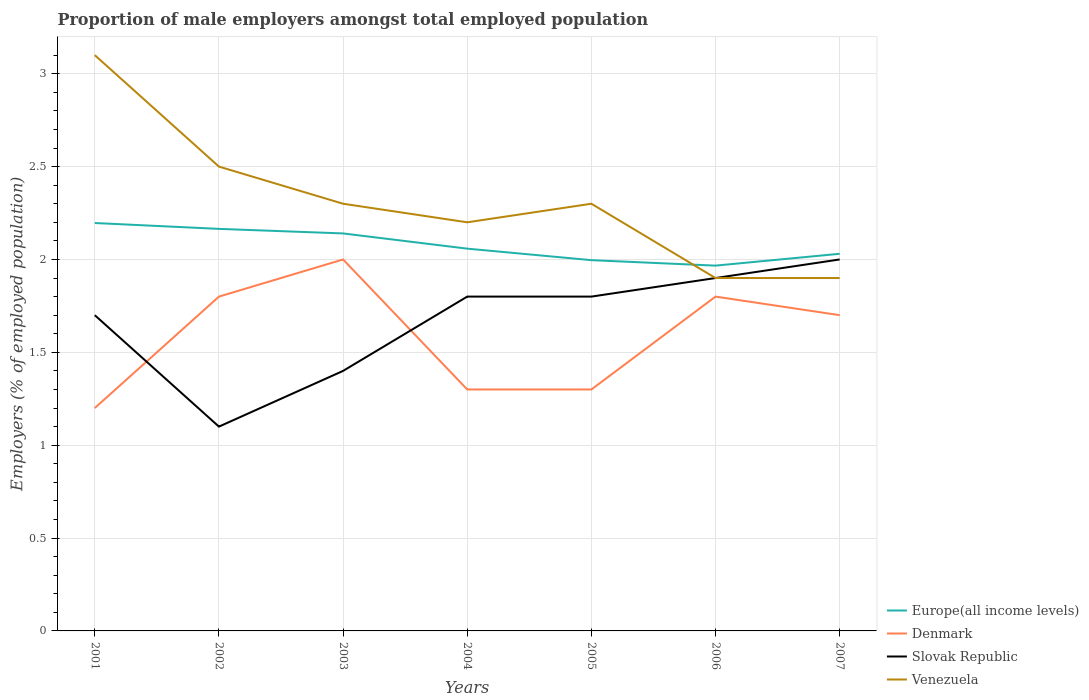How many different coloured lines are there?
Keep it short and to the point. 4. Across all years, what is the maximum proportion of male employers in Venezuela?
Provide a succinct answer. 1.9. In which year was the proportion of male employers in Denmark maximum?
Give a very brief answer. 2001. What is the total proportion of male employers in Denmark in the graph?
Give a very brief answer. -0.1. What is the difference between the highest and the second highest proportion of male employers in Europe(all income levels)?
Give a very brief answer. 0.23. How many years are there in the graph?
Make the answer very short. 7. What is the difference between two consecutive major ticks on the Y-axis?
Ensure brevity in your answer.  0.5. Are the values on the major ticks of Y-axis written in scientific E-notation?
Keep it short and to the point. No. Does the graph contain any zero values?
Your answer should be compact. No. How many legend labels are there?
Ensure brevity in your answer.  4. What is the title of the graph?
Offer a terse response. Proportion of male employers amongst total employed population. What is the label or title of the X-axis?
Provide a succinct answer. Years. What is the label or title of the Y-axis?
Your response must be concise. Employers (% of employed population). What is the Employers (% of employed population) in Europe(all income levels) in 2001?
Provide a short and direct response. 2.2. What is the Employers (% of employed population) of Denmark in 2001?
Your answer should be compact. 1.2. What is the Employers (% of employed population) in Slovak Republic in 2001?
Give a very brief answer. 1.7. What is the Employers (% of employed population) in Venezuela in 2001?
Your answer should be very brief. 3.1. What is the Employers (% of employed population) in Europe(all income levels) in 2002?
Offer a very short reply. 2.16. What is the Employers (% of employed population) of Denmark in 2002?
Your answer should be compact. 1.8. What is the Employers (% of employed population) of Slovak Republic in 2002?
Offer a terse response. 1.1. What is the Employers (% of employed population) of Europe(all income levels) in 2003?
Ensure brevity in your answer.  2.14. What is the Employers (% of employed population) in Denmark in 2003?
Offer a very short reply. 2. What is the Employers (% of employed population) in Slovak Republic in 2003?
Keep it short and to the point. 1.4. What is the Employers (% of employed population) of Venezuela in 2003?
Make the answer very short. 2.3. What is the Employers (% of employed population) in Europe(all income levels) in 2004?
Offer a terse response. 2.06. What is the Employers (% of employed population) in Denmark in 2004?
Provide a short and direct response. 1.3. What is the Employers (% of employed population) in Slovak Republic in 2004?
Ensure brevity in your answer.  1.8. What is the Employers (% of employed population) in Venezuela in 2004?
Give a very brief answer. 2.2. What is the Employers (% of employed population) of Europe(all income levels) in 2005?
Provide a short and direct response. 2. What is the Employers (% of employed population) in Denmark in 2005?
Provide a succinct answer. 1.3. What is the Employers (% of employed population) in Slovak Republic in 2005?
Provide a short and direct response. 1.8. What is the Employers (% of employed population) in Venezuela in 2005?
Give a very brief answer. 2.3. What is the Employers (% of employed population) of Europe(all income levels) in 2006?
Make the answer very short. 1.97. What is the Employers (% of employed population) in Denmark in 2006?
Your answer should be very brief. 1.8. What is the Employers (% of employed population) of Slovak Republic in 2006?
Provide a short and direct response. 1.9. What is the Employers (% of employed population) in Venezuela in 2006?
Offer a terse response. 1.9. What is the Employers (% of employed population) in Europe(all income levels) in 2007?
Your answer should be compact. 2.03. What is the Employers (% of employed population) in Denmark in 2007?
Offer a terse response. 1.7. What is the Employers (% of employed population) in Venezuela in 2007?
Offer a very short reply. 1.9. Across all years, what is the maximum Employers (% of employed population) in Europe(all income levels)?
Ensure brevity in your answer.  2.2. Across all years, what is the maximum Employers (% of employed population) of Denmark?
Your response must be concise. 2. Across all years, what is the maximum Employers (% of employed population) of Slovak Republic?
Your answer should be very brief. 2. Across all years, what is the maximum Employers (% of employed population) in Venezuela?
Make the answer very short. 3.1. Across all years, what is the minimum Employers (% of employed population) in Europe(all income levels)?
Offer a very short reply. 1.97. Across all years, what is the minimum Employers (% of employed population) of Denmark?
Your answer should be very brief. 1.2. Across all years, what is the minimum Employers (% of employed population) of Slovak Republic?
Make the answer very short. 1.1. Across all years, what is the minimum Employers (% of employed population) in Venezuela?
Your response must be concise. 1.9. What is the total Employers (% of employed population) of Europe(all income levels) in the graph?
Give a very brief answer. 14.55. What is the difference between the Employers (% of employed population) of Europe(all income levels) in 2001 and that in 2002?
Your response must be concise. 0.03. What is the difference between the Employers (% of employed population) in Venezuela in 2001 and that in 2002?
Your response must be concise. 0.6. What is the difference between the Employers (% of employed population) of Europe(all income levels) in 2001 and that in 2003?
Provide a succinct answer. 0.06. What is the difference between the Employers (% of employed population) of Slovak Republic in 2001 and that in 2003?
Give a very brief answer. 0.3. What is the difference between the Employers (% of employed population) in Venezuela in 2001 and that in 2003?
Provide a succinct answer. 0.8. What is the difference between the Employers (% of employed population) of Europe(all income levels) in 2001 and that in 2004?
Your response must be concise. 0.14. What is the difference between the Employers (% of employed population) in Slovak Republic in 2001 and that in 2004?
Your answer should be very brief. -0.1. What is the difference between the Employers (% of employed population) of Venezuela in 2001 and that in 2004?
Ensure brevity in your answer.  0.9. What is the difference between the Employers (% of employed population) of Europe(all income levels) in 2001 and that in 2005?
Your answer should be compact. 0.2. What is the difference between the Employers (% of employed population) in Venezuela in 2001 and that in 2005?
Offer a very short reply. 0.8. What is the difference between the Employers (% of employed population) of Europe(all income levels) in 2001 and that in 2006?
Ensure brevity in your answer.  0.23. What is the difference between the Employers (% of employed population) of Denmark in 2001 and that in 2006?
Your answer should be compact. -0.6. What is the difference between the Employers (% of employed population) of Slovak Republic in 2001 and that in 2006?
Offer a very short reply. -0.2. What is the difference between the Employers (% of employed population) of Europe(all income levels) in 2001 and that in 2007?
Provide a short and direct response. 0.17. What is the difference between the Employers (% of employed population) of Denmark in 2001 and that in 2007?
Your answer should be very brief. -0.5. What is the difference between the Employers (% of employed population) in Slovak Republic in 2001 and that in 2007?
Ensure brevity in your answer.  -0.3. What is the difference between the Employers (% of employed population) in Venezuela in 2001 and that in 2007?
Offer a very short reply. 1.2. What is the difference between the Employers (% of employed population) of Europe(all income levels) in 2002 and that in 2003?
Keep it short and to the point. 0.02. What is the difference between the Employers (% of employed population) of Denmark in 2002 and that in 2003?
Keep it short and to the point. -0.2. What is the difference between the Employers (% of employed population) in Slovak Republic in 2002 and that in 2003?
Ensure brevity in your answer.  -0.3. What is the difference between the Employers (% of employed population) in Venezuela in 2002 and that in 2003?
Provide a succinct answer. 0.2. What is the difference between the Employers (% of employed population) in Europe(all income levels) in 2002 and that in 2004?
Give a very brief answer. 0.11. What is the difference between the Employers (% of employed population) of Denmark in 2002 and that in 2004?
Give a very brief answer. 0.5. What is the difference between the Employers (% of employed population) in Slovak Republic in 2002 and that in 2004?
Your response must be concise. -0.7. What is the difference between the Employers (% of employed population) of Europe(all income levels) in 2002 and that in 2005?
Give a very brief answer. 0.17. What is the difference between the Employers (% of employed population) in Venezuela in 2002 and that in 2005?
Your answer should be compact. 0.2. What is the difference between the Employers (% of employed population) of Europe(all income levels) in 2002 and that in 2006?
Keep it short and to the point. 0.2. What is the difference between the Employers (% of employed population) in Venezuela in 2002 and that in 2006?
Provide a succinct answer. 0.6. What is the difference between the Employers (% of employed population) of Europe(all income levels) in 2002 and that in 2007?
Make the answer very short. 0.13. What is the difference between the Employers (% of employed population) of Denmark in 2002 and that in 2007?
Your answer should be very brief. 0.1. What is the difference between the Employers (% of employed population) in Slovak Republic in 2002 and that in 2007?
Make the answer very short. -0.9. What is the difference between the Employers (% of employed population) in Europe(all income levels) in 2003 and that in 2004?
Your answer should be very brief. 0.08. What is the difference between the Employers (% of employed population) of Denmark in 2003 and that in 2004?
Your answer should be very brief. 0.7. What is the difference between the Employers (% of employed population) in Slovak Republic in 2003 and that in 2004?
Give a very brief answer. -0.4. What is the difference between the Employers (% of employed population) of Venezuela in 2003 and that in 2004?
Ensure brevity in your answer.  0.1. What is the difference between the Employers (% of employed population) in Europe(all income levels) in 2003 and that in 2005?
Ensure brevity in your answer.  0.14. What is the difference between the Employers (% of employed population) in Europe(all income levels) in 2003 and that in 2006?
Your answer should be compact. 0.17. What is the difference between the Employers (% of employed population) of Denmark in 2003 and that in 2006?
Your answer should be very brief. 0.2. What is the difference between the Employers (% of employed population) in Venezuela in 2003 and that in 2006?
Offer a very short reply. 0.4. What is the difference between the Employers (% of employed population) in Europe(all income levels) in 2003 and that in 2007?
Ensure brevity in your answer.  0.11. What is the difference between the Employers (% of employed population) of Venezuela in 2003 and that in 2007?
Your response must be concise. 0.4. What is the difference between the Employers (% of employed population) in Europe(all income levels) in 2004 and that in 2005?
Your answer should be very brief. 0.06. What is the difference between the Employers (% of employed population) in Europe(all income levels) in 2004 and that in 2006?
Your response must be concise. 0.09. What is the difference between the Employers (% of employed population) of Denmark in 2004 and that in 2006?
Provide a short and direct response. -0.5. What is the difference between the Employers (% of employed population) in Venezuela in 2004 and that in 2006?
Ensure brevity in your answer.  0.3. What is the difference between the Employers (% of employed population) of Europe(all income levels) in 2004 and that in 2007?
Keep it short and to the point. 0.03. What is the difference between the Employers (% of employed population) in Denmark in 2004 and that in 2007?
Your answer should be compact. -0.4. What is the difference between the Employers (% of employed population) of Venezuela in 2004 and that in 2007?
Your answer should be very brief. 0.3. What is the difference between the Employers (% of employed population) in Europe(all income levels) in 2005 and that in 2006?
Your answer should be very brief. 0.03. What is the difference between the Employers (% of employed population) in Denmark in 2005 and that in 2006?
Ensure brevity in your answer.  -0.5. What is the difference between the Employers (% of employed population) in Slovak Republic in 2005 and that in 2006?
Ensure brevity in your answer.  -0.1. What is the difference between the Employers (% of employed population) in Venezuela in 2005 and that in 2006?
Your answer should be very brief. 0.4. What is the difference between the Employers (% of employed population) in Europe(all income levels) in 2005 and that in 2007?
Offer a very short reply. -0.03. What is the difference between the Employers (% of employed population) of Denmark in 2005 and that in 2007?
Provide a short and direct response. -0.4. What is the difference between the Employers (% of employed population) of Slovak Republic in 2005 and that in 2007?
Provide a short and direct response. -0.2. What is the difference between the Employers (% of employed population) of Europe(all income levels) in 2006 and that in 2007?
Offer a very short reply. -0.06. What is the difference between the Employers (% of employed population) in Denmark in 2006 and that in 2007?
Make the answer very short. 0.1. What is the difference between the Employers (% of employed population) in Slovak Republic in 2006 and that in 2007?
Keep it short and to the point. -0.1. What is the difference between the Employers (% of employed population) of Venezuela in 2006 and that in 2007?
Your answer should be very brief. 0. What is the difference between the Employers (% of employed population) of Europe(all income levels) in 2001 and the Employers (% of employed population) of Denmark in 2002?
Keep it short and to the point. 0.4. What is the difference between the Employers (% of employed population) of Europe(all income levels) in 2001 and the Employers (% of employed population) of Slovak Republic in 2002?
Your response must be concise. 1.1. What is the difference between the Employers (% of employed population) of Europe(all income levels) in 2001 and the Employers (% of employed population) of Venezuela in 2002?
Keep it short and to the point. -0.3. What is the difference between the Employers (% of employed population) in Denmark in 2001 and the Employers (% of employed population) in Slovak Republic in 2002?
Provide a succinct answer. 0.1. What is the difference between the Employers (% of employed population) in Europe(all income levels) in 2001 and the Employers (% of employed population) in Denmark in 2003?
Your answer should be compact. 0.2. What is the difference between the Employers (% of employed population) in Europe(all income levels) in 2001 and the Employers (% of employed population) in Slovak Republic in 2003?
Make the answer very short. 0.8. What is the difference between the Employers (% of employed population) in Europe(all income levels) in 2001 and the Employers (% of employed population) in Venezuela in 2003?
Your response must be concise. -0.1. What is the difference between the Employers (% of employed population) in Denmark in 2001 and the Employers (% of employed population) in Slovak Republic in 2003?
Ensure brevity in your answer.  -0.2. What is the difference between the Employers (% of employed population) in Europe(all income levels) in 2001 and the Employers (% of employed population) in Denmark in 2004?
Give a very brief answer. 0.9. What is the difference between the Employers (% of employed population) of Europe(all income levels) in 2001 and the Employers (% of employed population) of Slovak Republic in 2004?
Offer a terse response. 0.4. What is the difference between the Employers (% of employed population) of Europe(all income levels) in 2001 and the Employers (% of employed population) of Venezuela in 2004?
Your response must be concise. -0. What is the difference between the Employers (% of employed population) in Denmark in 2001 and the Employers (% of employed population) in Venezuela in 2004?
Ensure brevity in your answer.  -1. What is the difference between the Employers (% of employed population) of Europe(all income levels) in 2001 and the Employers (% of employed population) of Denmark in 2005?
Your answer should be compact. 0.9. What is the difference between the Employers (% of employed population) of Europe(all income levels) in 2001 and the Employers (% of employed population) of Slovak Republic in 2005?
Offer a very short reply. 0.4. What is the difference between the Employers (% of employed population) of Europe(all income levels) in 2001 and the Employers (% of employed population) of Venezuela in 2005?
Offer a terse response. -0.1. What is the difference between the Employers (% of employed population) in Denmark in 2001 and the Employers (% of employed population) in Slovak Republic in 2005?
Ensure brevity in your answer.  -0.6. What is the difference between the Employers (% of employed population) of Denmark in 2001 and the Employers (% of employed population) of Venezuela in 2005?
Make the answer very short. -1.1. What is the difference between the Employers (% of employed population) of Europe(all income levels) in 2001 and the Employers (% of employed population) of Denmark in 2006?
Your answer should be compact. 0.4. What is the difference between the Employers (% of employed population) in Europe(all income levels) in 2001 and the Employers (% of employed population) in Slovak Republic in 2006?
Keep it short and to the point. 0.3. What is the difference between the Employers (% of employed population) in Europe(all income levels) in 2001 and the Employers (% of employed population) in Venezuela in 2006?
Your answer should be compact. 0.3. What is the difference between the Employers (% of employed population) in Denmark in 2001 and the Employers (% of employed population) in Slovak Republic in 2006?
Your answer should be compact. -0.7. What is the difference between the Employers (% of employed population) in Europe(all income levels) in 2001 and the Employers (% of employed population) in Denmark in 2007?
Provide a short and direct response. 0.5. What is the difference between the Employers (% of employed population) of Europe(all income levels) in 2001 and the Employers (% of employed population) of Slovak Republic in 2007?
Give a very brief answer. 0.2. What is the difference between the Employers (% of employed population) in Europe(all income levels) in 2001 and the Employers (% of employed population) in Venezuela in 2007?
Your answer should be compact. 0.3. What is the difference between the Employers (% of employed population) of Denmark in 2001 and the Employers (% of employed population) of Venezuela in 2007?
Ensure brevity in your answer.  -0.7. What is the difference between the Employers (% of employed population) of Europe(all income levels) in 2002 and the Employers (% of employed population) of Denmark in 2003?
Offer a very short reply. 0.16. What is the difference between the Employers (% of employed population) of Europe(all income levels) in 2002 and the Employers (% of employed population) of Slovak Republic in 2003?
Keep it short and to the point. 0.76. What is the difference between the Employers (% of employed population) in Europe(all income levels) in 2002 and the Employers (% of employed population) in Venezuela in 2003?
Provide a succinct answer. -0.14. What is the difference between the Employers (% of employed population) of Denmark in 2002 and the Employers (% of employed population) of Slovak Republic in 2003?
Your answer should be very brief. 0.4. What is the difference between the Employers (% of employed population) of Denmark in 2002 and the Employers (% of employed population) of Venezuela in 2003?
Your response must be concise. -0.5. What is the difference between the Employers (% of employed population) in Europe(all income levels) in 2002 and the Employers (% of employed population) in Denmark in 2004?
Give a very brief answer. 0.86. What is the difference between the Employers (% of employed population) of Europe(all income levels) in 2002 and the Employers (% of employed population) of Slovak Republic in 2004?
Your answer should be compact. 0.36. What is the difference between the Employers (% of employed population) of Europe(all income levels) in 2002 and the Employers (% of employed population) of Venezuela in 2004?
Offer a very short reply. -0.04. What is the difference between the Employers (% of employed population) in Slovak Republic in 2002 and the Employers (% of employed population) in Venezuela in 2004?
Your response must be concise. -1.1. What is the difference between the Employers (% of employed population) of Europe(all income levels) in 2002 and the Employers (% of employed population) of Denmark in 2005?
Keep it short and to the point. 0.86. What is the difference between the Employers (% of employed population) in Europe(all income levels) in 2002 and the Employers (% of employed population) in Slovak Republic in 2005?
Your answer should be very brief. 0.36. What is the difference between the Employers (% of employed population) of Europe(all income levels) in 2002 and the Employers (% of employed population) of Venezuela in 2005?
Your answer should be compact. -0.14. What is the difference between the Employers (% of employed population) of Denmark in 2002 and the Employers (% of employed population) of Slovak Republic in 2005?
Offer a terse response. 0. What is the difference between the Employers (% of employed population) of Europe(all income levels) in 2002 and the Employers (% of employed population) of Denmark in 2006?
Your answer should be very brief. 0.36. What is the difference between the Employers (% of employed population) in Europe(all income levels) in 2002 and the Employers (% of employed population) in Slovak Republic in 2006?
Offer a terse response. 0.26. What is the difference between the Employers (% of employed population) of Europe(all income levels) in 2002 and the Employers (% of employed population) of Venezuela in 2006?
Offer a terse response. 0.26. What is the difference between the Employers (% of employed population) of Denmark in 2002 and the Employers (% of employed population) of Slovak Republic in 2006?
Offer a terse response. -0.1. What is the difference between the Employers (% of employed population) of Denmark in 2002 and the Employers (% of employed population) of Venezuela in 2006?
Your answer should be compact. -0.1. What is the difference between the Employers (% of employed population) of Europe(all income levels) in 2002 and the Employers (% of employed population) of Denmark in 2007?
Keep it short and to the point. 0.46. What is the difference between the Employers (% of employed population) of Europe(all income levels) in 2002 and the Employers (% of employed population) of Slovak Republic in 2007?
Give a very brief answer. 0.16. What is the difference between the Employers (% of employed population) of Europe(all income levels) in 2002 and the Employers (% of employed population) of Venezuela in 2007?
Offer a terse response. 0.26. What is the difference between the Employers (% of employed population) in Denmark in 2002 and the Employers (% of employed population) in Venezuela in 2007?
Make the answer very short. -0.1. What is the difference between the Employers (% of employed population) in Slovak Republic in 2002 and the Employers (% of employed population) in Venezuela in 2007?
Offer a very short reply. -0.8. What is the difference between the Employers (% of employed population) of Europe(all income levels) in 2003 and the Employers (% of employed population) of Denmark in 2004?
Your response must be concise. 0.84. What is the difference between the Employers (% of employed population) in Europe(all income levels) in 2003 and the Employers (% of employed population) in Slovak Republic in 2004?
Make the answer very short. 0.34. What is the difference between the Employers (% of employed population) of Europe(all income levels) in 2003 and the Employers (% of employed population) of Venezuela in 2004?
Offer a very short reply. -0.06. What is the difference between the Employers (% of employed population) in Denmark in 2003 and the Employers (% of employed population) in Slovak Republic in 2004?
Your answer should be compact. 0.2. What is the difference between the Employers (% of employed population) in Denmark in 2003 and the Employers (% of employed population) in Venezuela in 2004?
Your response must be concise. -0.2. What is the difference between the Employers (% of employed population) in Slovak Republic in 2003 and the Employers (% of employed population) in Venezuela in 2004?
Make the answer very short. -0.8. What is the difference between the Employers (% of employed population) of Europe(all income levels) in 2003 and the Employers (% of employed population) of Denmark in 2005?
Make the answer very short. 0.84. What is the difference between the Employers (% of employed population) in Europe(all income levels) in 2003 and the Employers (% of employed population) in Slovak Republic in 2005?
Make the answer very short. 0.34. What is the difference between the Employers (% of employed population) in Europe(all income levels) in 2003 and the Employers (% of employed population) in Venezuela in 2005?
Your answer should be very brief. -0.16. What is the difference between the Employers (% of employed population) of Denmark in 2003 and the Employers (% of employed population) of Slovak Republic in 2005?
Your answer should be very brief. 0.2. What is the difference between the Employers (% of employed population) of Denmark in 2003 and the Employers (% of employed population) of Venezuela in 2005?
Offer a terse response. -0.3. What is the difference between the Employers (% of employed population) of Slovak Republic in 2003 and the Employers (% of employed population) of Venezuela in 2005?
Make the answer very short. -0.9. What is the difference between the Employers (% of employed population) in Europe(all income levels) in 2003 and the Employers (% of employed population) in Denmark in 2006?
Your response must be concise. 0.34. What is the difference between the Employers (% of employed population) in Europe(all income levels) in 2003 and the Employers (% of employed population) in Slovak Republic in 2006?
Make the answer very short. 0.24. What is the difference between the Employers (% of employed population) in Europe(all income levels) in 2003 and the Employers (% of employed population) in Venezuela in 2006?
Provide a short and direct response. 0.24. What is the difference between the Employers (% of employed population) in Denmark in 2003 and the Employers (% of employed population) in Venezuela in 2006?
Give a very brief answer. 0.1. What is the difference between the Employers (% of employed population) of Europe(all income levels) in 2003 and the Employers (% of employed population) of Denmark in 2007?
Offer a terse response. 0.44. What is the difference between the Employers (% of employed population) in Europe(all income levels) in 2003 and the Employers (% of employed population) in Slovak Republic in 2007?
Keep it short and to the point. 0.14. What is the difference between the Employers (% of employed population) in Europe(all income levels) in 2003 and the Employers (% of employed population) in Venezuela in 2007?
Give a very brief answer. 0.24. What is the difference between the Employers (% of employed population) of Denmark in 2003 and the Employers (% of employed population) of Slovak Republic in 2007?
Your answer should be compact. 0. What is the difference between the Employers (% of employed population) in Denmark in 2003 and the Employers (% of employed population) in Venezuela in 2007?
Offer a very short reply. 0.1. What is the difference between the Employers (% of employed population) of Slovak Republic in 2003 and the Employers (% of employed population) of Venezuela in 2007?
Ensure brevity in your answer.  -0.5. What is the difference between the Employers (% of employed population) of Europe(all income levels) in 2004 and the Employers (% of employed population) of Denmark in 2005?
Provide a short and direct response. 0.76. What is the difference between the Employers (% of employed population) of Europe(all income levels) in 2004 and the Employers (% of employed population) of Slovak Republic in 2005?
Your answer should be compact. 0.26. What is the difference between the Employers (% of employed population) of Europe(all income levels) in 2004 and the Employers (% of employed population) of Venezuela in 2005?
Offer a terse response. -0.24. What is the difference between the Employers (% of employed population) in Slovak Republic in 2004 and the Employers (% of employed population) in Venezuela in 2005?
Offer a terse response. -0.5. What is the difference between the Employers (% of employed population) in Europe(all income levels) in 2004 and the Employers (% of employed population) in Denmark in 2006?
Your answer should be very brief. 0.26. What is the difference between the Employers (% of employed population) in Europe(all income levels) in 2004 and the Employers (% of employed population) in Slovak Republic in 2006?
Your response must be concise. 0.16. What is the difference between the Employers (% of employed population) of Europe(all income levels) in 2004 and the Employers (% of employed population) of Venezuela in 2006?
Keep it short and to the point. 0.16. What is the difference between the Employers (% of employed population) in Denmark in 2004 and the Employers (% of employed population) in Venezuela in 2006?
Provide a short and direct response. -0.6. What is the difference between the Employers (% of employed population) of Europe(all income levels) in 2004 and the Employers (% of employed population) of Denmark in 2007?
Provide a succinct answer. 0.36. What is the difference between the Employers (% of employed population) of Europe(all income levels) in 2004 and the Employers (% of employed population) of Slovak Republic in 2007?
Offer a terse response. 0.06. What is the difference between the Employers (% of employed population) of Europe(all income levels) in 2004 and the Employers (% of employed population) of Venezuela in 2007?
Your answer should be very brief. 0.16. What is the difference between the Employers (% of employed population) in Denmark in 2004 and the Employers (% of employed population) in Slovak Republic in 2007?
Make the answer very short. -0.7. What is the difference between the Employers (% of employed population) in Slovak Republic in 2004 and the Employers (% of employed population) in Venezuela in 2007?
Provide a short and direct response. -0.1. What is the difference between the Employers (% of employed population) in Europe(all income levels) in 2005 and the Employers (% of employed population) in Denmark in 2006?
Give a very brief answer. 0.2. What is the difference between the Employers (% of employed population) of Europe(all income levels) in 2005 and the Employers (% of employed population) of Slovak Republic in 2006?
Your answer should be very brief. 0.1. What is the difference between the Employers (% of employed population) of Europe(all income levels) in 2005 and the Employers (% of employed population) of Venezuela in 2006?
Keep it short and to the point. 0.1. What is the difference between the Employers (% of employed population) of Denmark in 2005 and the Employers (% of employed population) of Slovak Republic in 2006?
Your answer should be very brief. -0.6. What is the difference between the Employers (% of employed population) in Denmark in 2005 and the Employers (% of employed population) in Venezuela in 2006?
Keep it short and to the point. -0.6. What is the difference between the Employers (% of employed population) of Europe(all income levels) in 2005 and the Employers (% of employed population) of Denmark in 2007?
Make the answer very short. 0.3. What is the difference between the Employers (% of employed population) of Europe(all income levels) in 2005 and the Employers (% of employed population) of Slovak Republic in 2007?
Make the answer very short. -0. What is the difference between the Employers (% of employed population) in Europe(all income levels) in 2005 and the Employers (% of employed population) in Venezuela in 2007?
Make the answer very short. 0.1. What is the difference between the Employers (% of employed population) of Denmark in 2005 and the Employers (% of employed population) of Venezuela in 2007?
Your answer should be very brief. -0.6. What is the difference between the Employers (% of employed population) in Europe(all income levels) in 2006 and the Employers (% of employed population) in Denmark in 2007?
Provide a succinct answer. 0.27. What is the difference between the Employers (% of employed population) of Europe(all income levels) in 2006 and the Employers (% of employed population) of Slovak Republic in 2007?
Provide a short and direct response. -0.03. What is the difference between the Employers (% of employed population) of Europe(all income levels) in 2006 and the Employers (% of employed population) of Venezuela in 2007?
Provide a short and direct response. 0.07. What is the difference between the Employers (% of employed population) in Denmark in 2006 and the Employers (% of employed population) in Venezuela in 2007?
Make the answer very short. -0.1. What is the difference between the Employers (% of employed population) in Slovak Republic in 2006 and the Employers (% of employed population) in Venezuela in 2007?
Provide a succinct answer. 0. What is the average Employers (% of employed population) of Europe(all income levels) per year?
Your answer should be very brief. 2.08. What is the average Employers (% of employed population) in Denmark per year?
Give a very brief answer. 1.59. What is the average Employers (% of employed population) in Slovak Republic per year?
Your answer should be very brief. 1.67. What is the average Employers (% of employed population) of Venezuela per year?
Give a very brief answer. 2.31. In the year 2001, what is the difference between the Employers (% of employed population) of Europe(all income levels) and Employers (% of employed population) of Slovak Republic?
Keep it short and to the point. 0.5. In the year 2001, what is the difference between the Employers (% of employed population) in Europe(all income levels) and Employers (% of employed population) in Venezuela?
Your answer should be compact. -0.9. In the year 2001, what is the difference between the Employers (% of employed population) in Denmark and Employers (% of employed population) in Venezuela?
Provide a succinct answer. -1.9. In the year 2002, what is the difference between the Employers (% of employed population) of Europe(all income levels) and Employers (% of employed population) of Denmark?
Keep it short and to the point. 0.36. In the year 2002, what is the difference between the Employers (% of employed population) of Europe(all income levels) and Employers (% of employed population) of Slovak Republic?
Give a very brief answer. 1.06. In the year 2002, what is the difference between the Employers (% of employed population) in Europe(all income levels) and Employers (% of employed population) in Venezuela?
Provide a succinct answer. -0.34. In the year 2002, what is the difference between the Employers (% of employed population) in Slovak Republic and Employers (% of employed population) in Venezuela?
Offer a terse response. -1.4. In the year 2003, what is the difference between the Employers (% of employed population) in Europe(all income levels) and Employers (% of employed population) in Denmark?
Keep it short and to the point. 0.14. In the year 2003, what is the difference between the Employers (% of employed population) of Europe(all income levels) and Employers (% of employed population) of Slovak Republic?
Your answer should be very brief. 0.74. In the year 2003, what is the difference between the Employers (% of employed population) of Europe(all income levels) and Employers (% of employed population) of Venezuela?
Your answer should be compact. -0.16. In the year 2003, what is the difference between the Employers (% of employed population) of Denmark and Employers (% of employed population) of Slovak Republic?
Make the answer very short. 0.6. In the year 2003, what is the difference between the Employers (% of employed population) in Denmark and Employers (% of employed population) in Venezuela?
Your answer should be compact. -0.3. In the year 2003, what is the difference between the Employers (% of employed population) in Slovak Republic and Employers (% of employed population) in Venezuela?
Your answer should be compact. -0.9. In the year 2004, what is the difference between the Employers (% of employed population) of Europe(all income levels) and Employers (% of employed population) of Denmark?
Make the answer very short. 0.76. In the year 2004, what is the difference between the Employers (% of employed population) in Europe(all income levels) and Employers (% of employed population) in Slovak Republic?
Your answer should be very brief. 0.26. In the year 2004, what is the difference between the Employers (% of employed population) in Europe(all income levels) and Employers (% of employed population) in Venezuela?
Make the answer very short. -0.14. In the year 2004, what is the difference between the Employers (% of employed population) in Denmark and Employers (% of employed population) in Venezuela?
Your response must be concise. -0.9. In the year 2004, what is the difference between the Employers (% of employed population) in Slovak Republic and Employers (% of employed population) in Venezuela?
Give a very brief answer. -0.4. In the year 2005, what is the difference between the Employers (% of employed population) of Europe(all income levels) and Employers (% of employed population) of Denmark?
Make the answer very short. 0.7. In the year 2005, what is the difference between the Employers (% of employed population) in Europe(all income levels) and Employers (% of employed population) in Slovak Republic?
Provide a succinct answer. 0.2. In the year 2005, what is the difference between the Employers (% of employed population) of Europe(all income levels) and Employers (% of employed population) of Venezuela?
Offer a terse response. -0.3. In the year 2005, what is the difference between the Employers (% of employed population) of Denmark and Employers (% of employed population) of Slovak Republic?
Provide a succinct answer. -0.5. In the year 2006, what is the difference between the Employers (% of employed population) in Europe(all income levels) and Employers (% of employed population) in Denmark?
Your answer should be very brief. 0.17. In the year 2006, what is the difference between the Employers (% of employed population) in Europe(all income levels) and Employers (% of employed population) in Slovak Republic?
Keep it short and to the point. 0.07. In the year 2006, what is the difference between the Employers (% of employed population) in Europe(all income levels) and Employers (% of employed population) in Venezuela?
Your answer should be compact. 0.07. In the year 2006, what is the difference between the Employers (% of employed population) of Denmark and Employers (% of employed population) of Slovak Republic?
Your answer should be very brief. -0.1. In the year 2006, what is the difference between the Employers (% of employed population) in Denmark and Employers (% of employed population) in Venezuela?
Offer a terse response. -0.1. In the year 2007, what is the difference between the Employers (% of employed population) of Europe(all income levels) and Employers (% of employed population) of Denmark?
Your answer should be very brief. 0.33. In the year 2007, what is the difference between the Employers (% of employed population) in Europe(all income levels) and Employers (% of employed population) in Slovak Republic?
Your answer should be very brief. 0.03. In the year 2007, what is the difference between the Employers (% of employed population) in Europe(all income levels) and Employers (% of employed population) in Venezuela?
Your answer should be compact. 0.13. In the year 2007, what is the difference between the Employers (% of employed population) in Slovak Republic and Employers (% of employed population) in Venezuela?
Give a very brief answer. 0.1. What is the ratio of the Employers (% of employed population) in Europe(all income levels) in 2001 to that in 2002?
Keep it short and to the point. 1.01. What is the ratio of the Employers (% of employed population) of Slovak Republic in 2001 to that in 2002?
Offer a very short reply. 1.55. What is the ratio of the Employers (% of employed population) of Venezuela in 2001 to that in 2002?
Make the answer very short. 1.24. What is the ratio of the Employers (% of employed population) of Europe(all income levels) in 2001 to that in 2003?
Your answer should be compact. 1.03. What is the ratio of the Employers (% of employed population) of Slovak Republic in 2001 to that in 2003?
Your answer should be very brief. 1.21. What is the ratio of the Employers (% of employed population) of Venezuela in 2001 to that in 2003?
Offer a terse response. 1.35. What is the ratio of the Employers (% of employed population) in Europe(all income levels) in 2001 to that in 2004?
Offer a terse response. 1.07. What is the ratio of the Employers (% of employed population) in Venezuela in 2001 to that in 2004?
Ensure brevity in your answer.  1.41. What is the ratio of the Employers (% of employed population) in Europe(all income levels) in 2001 to that in 2005?
Give a very brief answer. 1.1. What is the ratio of the Employers (% of employed population) of Denmark in 2001 to that in 2005?
Keep it short and to the point. 0.92. What is the ratio of the Employers (% of employed population) in Slovak Republic in 2001 to that in 2005?
Offer a terse response. 0.94. What is the ratio of the Employers (% of employed population) of Venezuela in 2001 to that in 2005?
Your answer should be very brief. 1.35. What is the ratio of the Employers (% of employed population) of Europe(all income levels) in 2001 to that in 2006?
Provide a short and direct response. 1.12. What is the ratio of the Employers (% of employed population) of Slovak Republic in 2001 to that in 2006?
Your answer should be very brief. 0.89. What is the ratio of the Employers (% of employed population) of Venezuela in 2001 to that in 2006?
Keep it short and to the point. 1.63. What is the ratio of the Employers (% of employed population) in Europe(all income levels) in 2001 to that in 2007?
Give a very brief answer. 1.08. What is the ratio of the Employers (% of employed population) of Denmark in 2001 to that in 2007?
Your answer should be compact. 0.71. What is the ratio of the Employers (% of employed population) in Venezuela in 2001 to that in 2007?
Ensure brevity in your answer.  1.63. What is the ratio of the Employers (% of employed population) of Europe(all income levels) in 2002 to that in 2003?
Offer a very short reply. 1.01. What is the ratio of the Employers (% of employed population) of Denmark in 2002 to that in 2003?
Give a very brief answer. 0.9. What is the ratio of the Employers (% of employed population) in Slovak Republic in 2002 to that in 2003?
Ensure brevity in your answer.  0.79. What is the ratio of the Employers (% of employed population) in Venezuela in 2002 to that in 2003?
Offer a terse response. 1.09. What is the ratio of the Employers (% of employed population) of Europe(all income levels) in 2002 to that in 2004?
Keep it short and to the point. 1.05. What is the ratio of the Employers (% of employed population) of Denmark in 2002 to that in 2004?
Make the answer very short. 1.38. What is the ratio of the Employers (% of employed population) of Slovak Republic in 2002 to that in 2004?
Offer a very short reply. 0.61. What is the ratio of the Employers (% of employed population) of Venezuela in 2002 to that in 2004?
Provide a short and direct response. 1.14. What is the ratio of the Employers (% of employed population) in Europe(all income levels) in 2002 to that in 2005?
Your response must be concise. 1.08. What is the ratio of the Employers (% of employed population) in Denmark in 2002 to that in 2005?
Ensure brevity in your answer.  1.38. What is the ratio of the Employers (% of employed population) in Slovak Republic in 2002 to that in 2005?
Offer a very short reply. 0.61. What is the ratio of the Employers (% of employed population) in Venezuela in 2002 to that in 2005?
Your response must be concise. 1.09. What is the ratio of the Employers (% of employed population) of Europe(all income levels) in 2002 to that in 2006?
Your answer should be compact. 1.1. What is the ratio of the Employers (% of employed population) in Denmark in 2002 to that in 2006?
Make the answer very short. 1. What is the ratio of the Employers (% of employed population) of Slovak Republic in 2002 to that in 2006?
Ensure brevity in your answer.  0.58. What is the ratio of the Employers (% of employed population) in Venezuela in 2002 to that in 2006?
Your answer should be compact. 1.32. What is the ratio of the Employers (% of employed population) in Europe(all income levels) in 2002 to that in 2007?
Your answer should be very brief. 1.07. What is the ratio of the Employers (% of employed population) of Denmark in 2002 to that in 2007?
Your answer should be compact. 1.06. What is the ratio of the Employers (% of employed population) of Slovak Republic in 2002 to that in 2007?
Ensure brevity in your answer.  0.55. What is the ratio of the Employers (% of employed population) in Venezuela in 2002 to that in 2007?
Ensure brevity in your answer.  1.32. What is the ratio of the Employers (% of employed population) in Europe(all income levels) in 2003 to that in 2004?
Offer a very short reply. 1.04. What is the ratio of the Employers (% of employed population) of Denmark in 2003 to that in 2004?
Ensure brevity in your answer.  1.54. What is the ratio of the Employers (% of employed population) in Slovak Republic in 2003 to that in 2004?
Make the answer very short. 0.78. What is the ratio of the Employers (% of employed population) in Venezuela in 2003 to that in 2004?
Your answer should be compact. 1.05. What is the ratio of the Employers (% of employed population) of Europe(all income levels) in 2003 to that in 2005?
Keep it short and to the point. 1.07. What is the ratio of the Employers (% of employed population) in Denmark in 2003 to that in 2005?
Make the answer very short. 1.54. What is the ratio of the Employers (% of employed population) in Venezuela in 2003 to that in 2005?
Offer a terse response. 1. What is the ratio of the Employers (% of employed population) in Europe(all income levels) in 2003 to that in 2006?
Make the answer very short. 1.09. What is the ratio of the Employers (% of employed population) of Denmark in 2003 to that in 2006?
Provide a short and direct response. 1.11. What is the ratio of the Employers (% of employed population) of Slovak Republic in 2003 to that in 2006?
Your response must be concise. 0.74. What is the ratio of the Employers (% of employed population) in Venezuela in 2003 to that in 2006?
Give a very brief answer. 1.21. What is the ratio of the Employers (% of employed population) of Europe(all income levels) in 2003 to that in 2007?
Offer a very short reply. 1.05. What is the ratio of the Employers (% of employed population) in Denmark in 2003 to that in 2007?
Ensure brevity in your answer.  1.18. What is the ratio of the Employers (% of employed population) of Venezuela in 2003 to that in 2007?
Offer a terse response. 1.21. What is the ratio of the Employers (% of employed population) in Europe(all income levels) in 2004 to that in 2005?
Give a very brief answer. 1.03. What is the ratio of the Employers (% of employed population) of Venezuela in 2004 to that in 2005?
Offer a very short reply. 0.96. What is the ratio of the Employers (% of employed population) of Europe(all income levels) in 2004 to that in 2006?
Ensure brevity in your answer.  1.05. What is the ratio of the Employers (% of employed population) of Denmark in 2004 to that in 2006?
Make the answer very short. 0.72. What is the ratio of the Employers (% of employed population) of Venezuela in 2004 to that in 2006?
Your answer should be very brief. 1.16. What is the ratio of the Employers (% of employed population) in Europe(all income levels) in 2004 to that in 2007?
Give a very brief answer. 1.01. What is the ratio of the Employers (% of employed population) of Denmark in 2004 to that in 2007?
Make the answer very short. 0.76. What is the ratio of the Employers (% of employed population) of Venezuela in 2004 to that in 2007?
Ensure brevity in your answer.  1.16. What is the ratio of the Employers (% of employed population) of Denmark in 2005 to that in 2006?
Offer a very short reply. 0.72. What is the ratio of the Employers (% of employed population) in Slovak Republic in 2005 to that in 2006?
Your answer should be very brief. 0.95. What is the ratio of the Employers (% of employed population) of Venezuela in 2005 to that in 2006?
Your answer should be compact. 1.21. What is the ratio of the Employers (% of employed population) in Europe(all income levels) in 2005 to that in 2007?
Keep it short and to the point. 0.98. What is the ratio of the Employers (% of employed population) in Denmark in 2005 to that in 2007?
Ensure brevity in your answer.  0.76. What is the ratio of the Employers (% of employed population) in Slovak Republic in 2005 to that in 2007?
Your answer should be very brief. 0.9. What is the ratio of the Employers (% of employed population) of Venezuela in 2005 to that in 2007?
Provide a short and direct response. 1.21. What is the ratio of the Employers (% of employed population) in Europe(all income levels) in 2006 to that in 2007?
Offer a terse response. 0.97. What is the ratio of the Employers (% of employed population) of Denmark in 2006 to that in 2007?
Your response must be concise. 1.06. What is the ratio of the Employers (% of employed population) of Venezuela in 2006 to that in 2007?
Keep it short and to the point. 1. What is the difference between the highest and the second highest Employers (% of employed population) in Europe(all income levels)?
Ensure brevity in your answer.  0.03. What is the difference between the highest and the second highest Employers (% of employed population) in Denmark?
Your response must be concise. 0.2. What is the difference between the highest and the second highest Employers (% of employed population) in Venezuela?
Your answer should be very brief. 0.6. What is the difference between the highest and the lowest Employers (% of employed population) of Europe(all income levels)?
Ensure brevity in your answer.  0.23. 